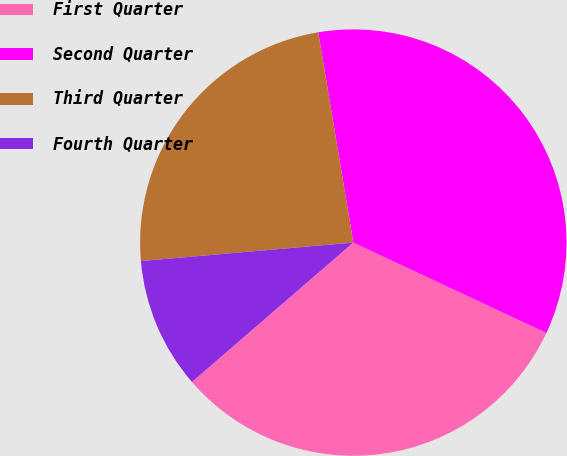Convert chart. <chart><loc_0><loc_0><loc_500><loc_500><pie_chart><fcel>First Quarter<fcel>Second Quarter<fcel>Third Quarter<fcel>Fourth Quarter<nl><fcel>31.69%<fcel>34.6%<fcel>23.75%<fcel>9.96%<nl></chart> 